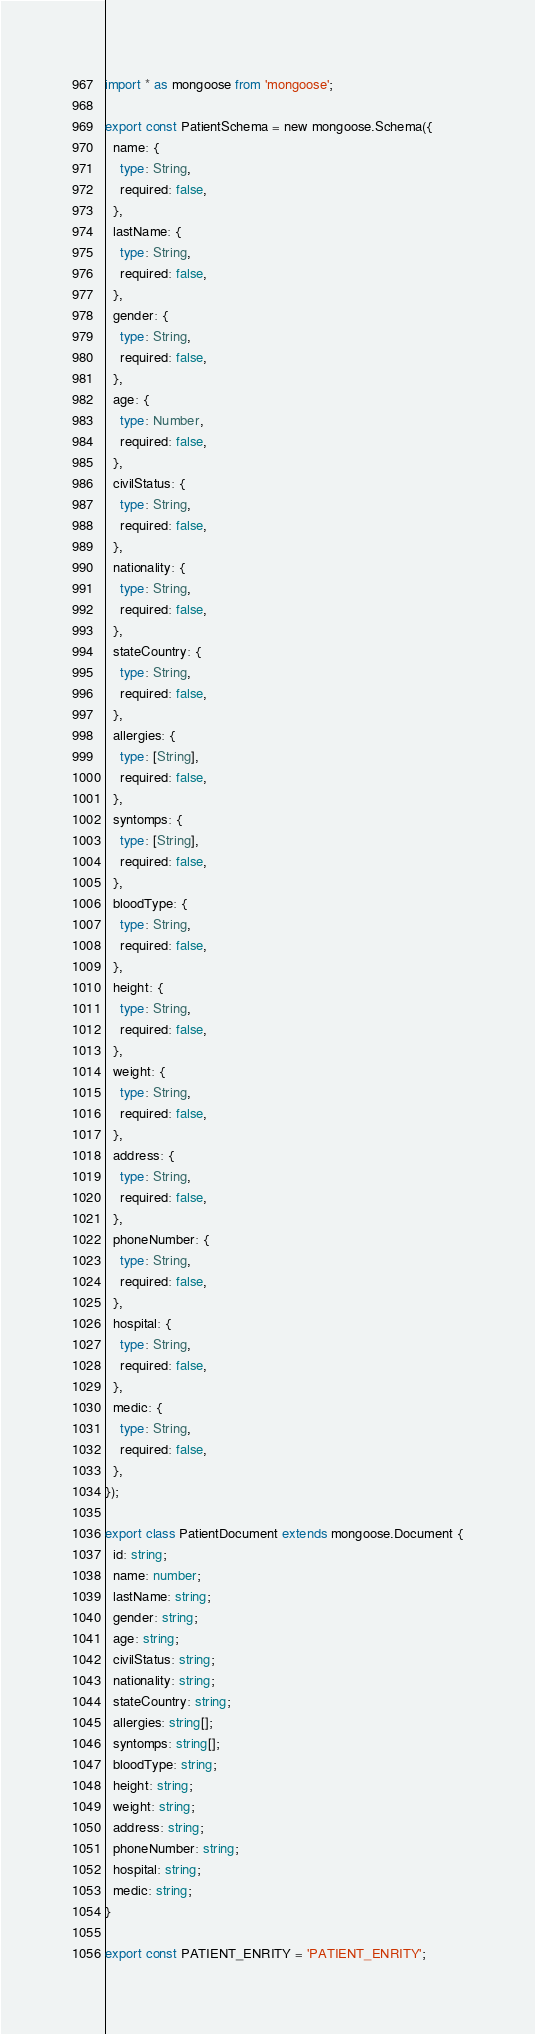<code> <loc_0><loc_0><loc_500><loc_500><_TypeScript_>import * as mongoose from 'mongoose';

export const PatientSchema = new mongoose.Schema({
  name: {
    type: String,
    required: false,
  },
  lastName: {
    type: String,
    required: false,
  },
  gender: {
    type: String,
    required: false,
  },
  age: {
    type: Number,
    required: false,
  },
  civilStatus: {
    type: String,
    required: false,
  },
  nationality: {
    type: String,
    required: false,
  },
  stateCountry: {
    type: String,
    required: false,
  },
  allergies: {
    type: [String],
    required: false,
  },
  syntomps: {
    type: [String],
    required: false,
  },
  bloodType: {
    type: String,
    required: false,
  },
  height: {
    type: String,
    required: false,
  },
  weight: {
    type: String,
    required: false,
  },
  address: {
    type: String,
    required: false,
  },
  phoneNumber: {
    type: String,
    required: false,
  },
  hospital: {
    type: String,
    required: false,
  },
  medic: {
    type: String,
    required: false,
  },
});

export class PatientDocument extends mongoose.Document {
  id: string;
  name: number;
  lastName: string;
  gender: string;
  age: string;
  civilStatus: string;
  nationality: string;
  stateCountry: string;
  allergies: string[];
  syntomps: string[];
  bloodType: string;
  height: string;
  weight: string;
  address: string;
  phoneNumber: string;
  hospital: string;
  medic: string;
}

export const PATIENT_ENRITY = 'PATIENT_ENRITY';
</code> 